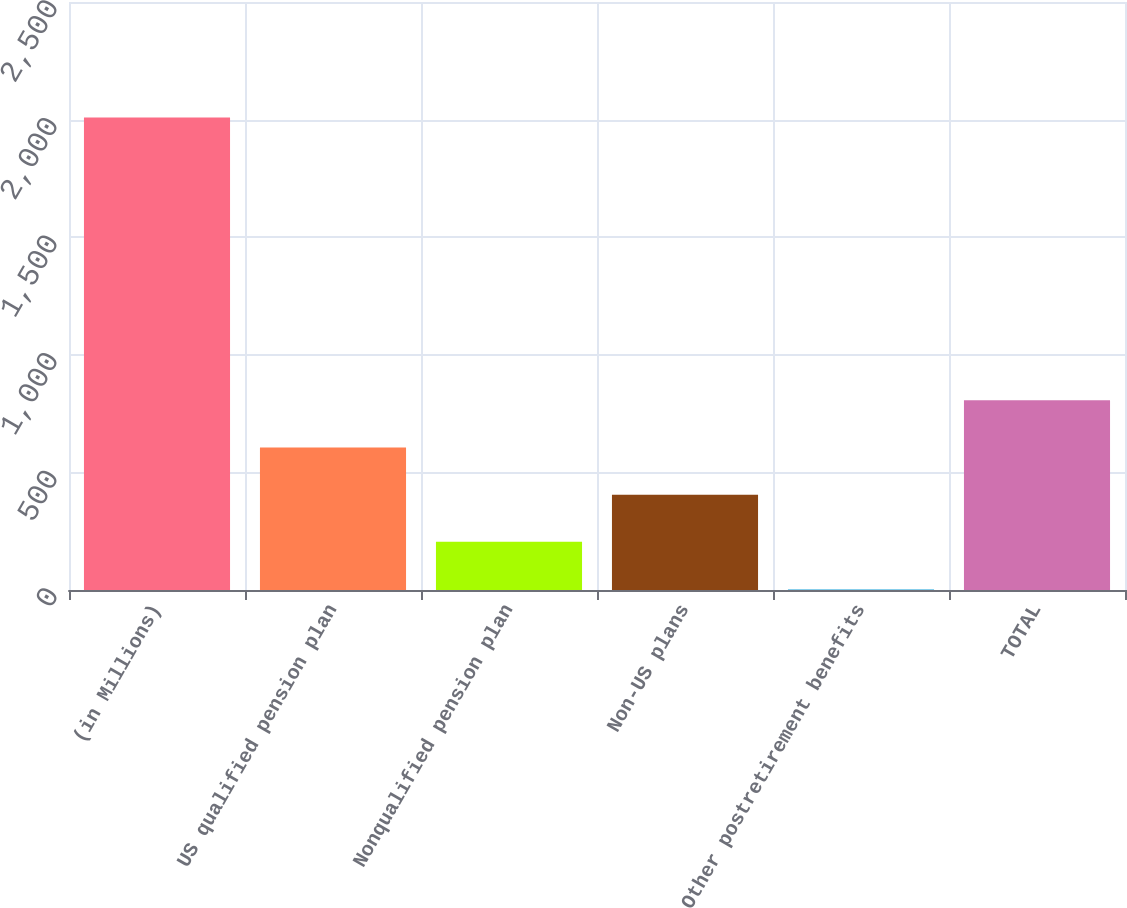Convert chart to OTSL. <chart><loc_0><loc_0><loc_500><loc_500><bar_chart><fcel>(in Millions)<fcel>US qualified pension plan<fcel>Nonqualified pension plan<fcel>Non-US plans<fcel>Other postretirement benefits<fcel>TOTAL<nl><fcel>2009<fcel>605.92<fcel>205.04<fcel>405.48<fcel>4.6<fcel>806.36<nl></chart> 